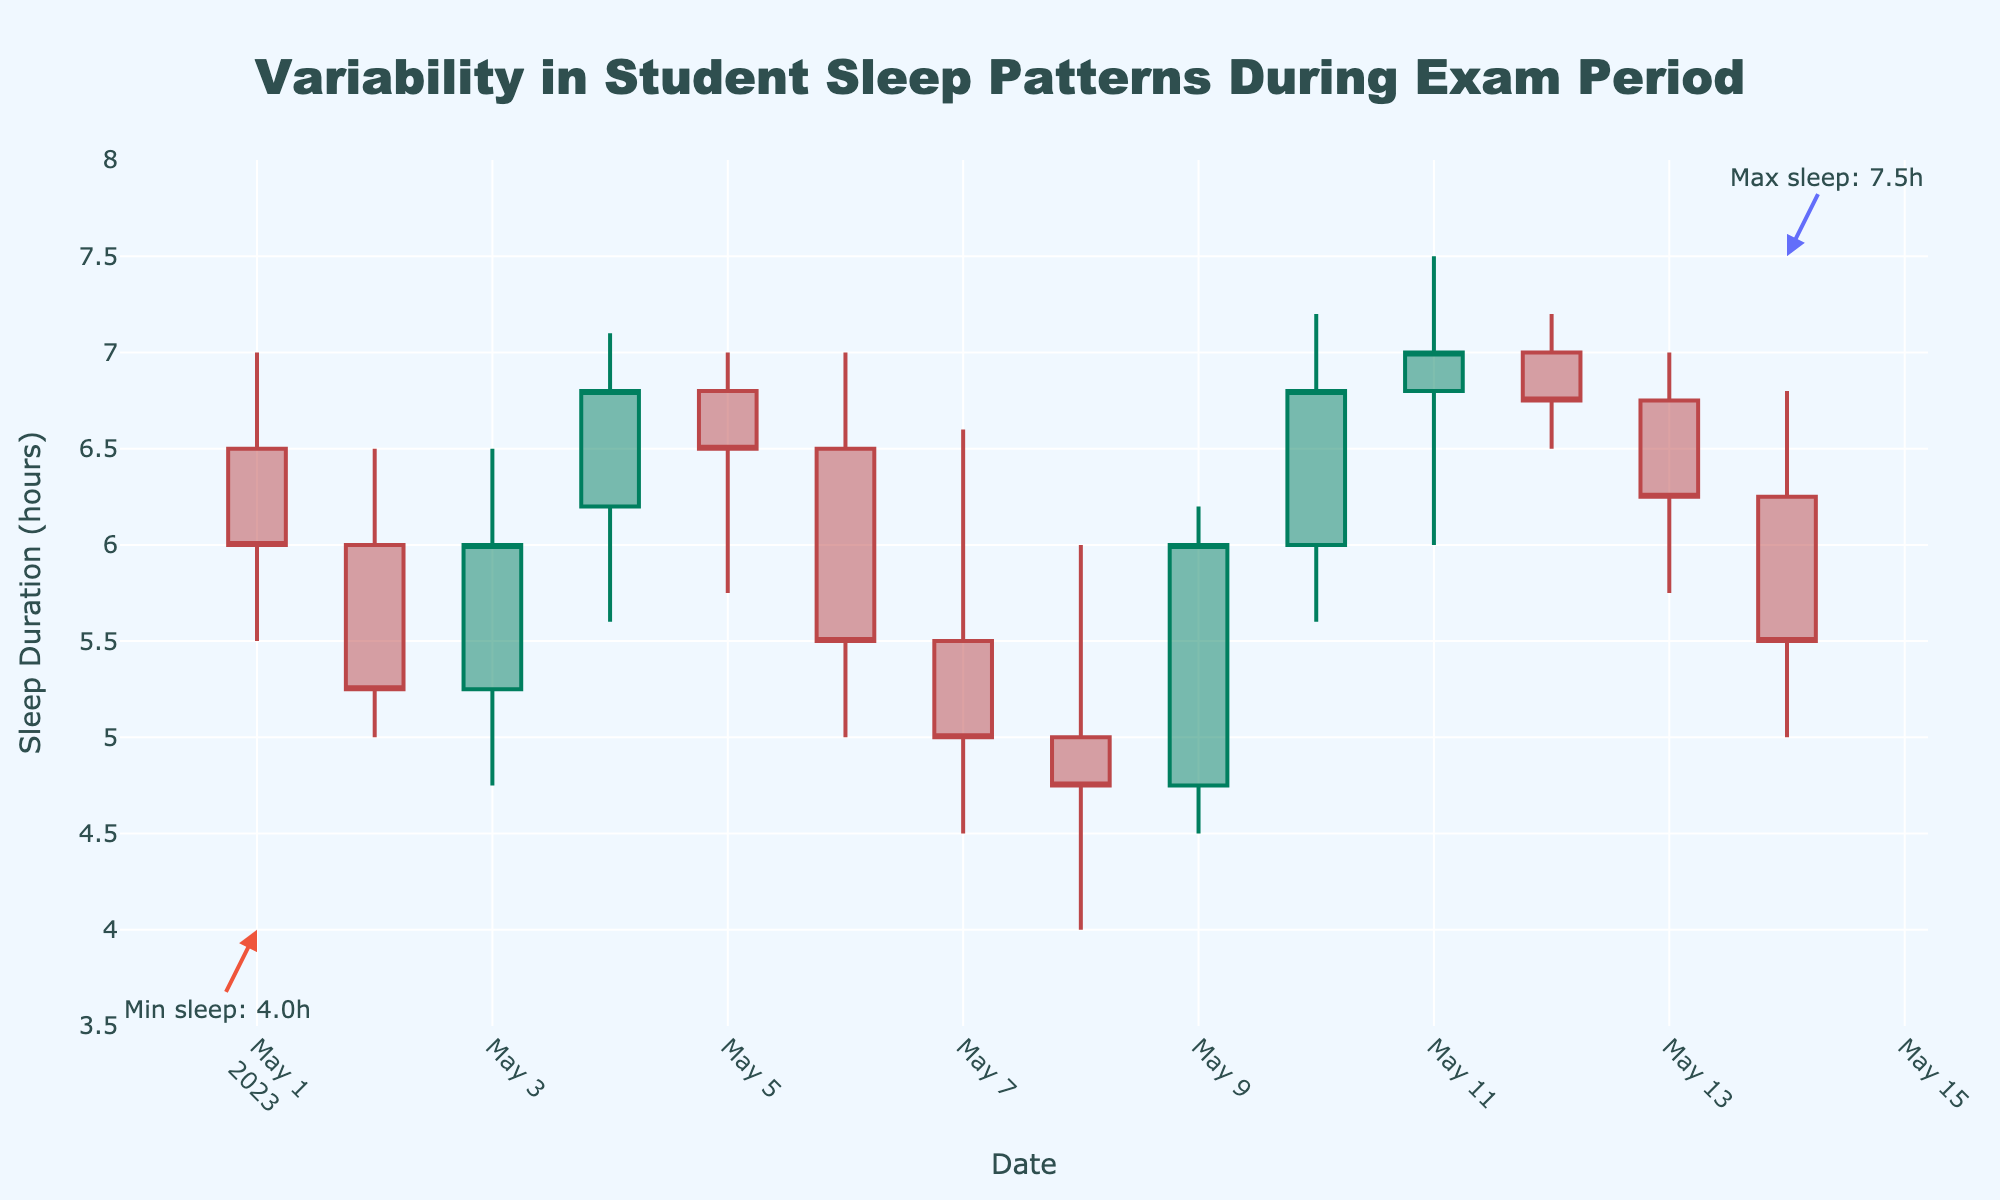What is the title of the figure? The title is prominently displayed at the top of the figure, providing a clear indication of what the plot represents.
Answer: Variability in Student Sleep Patterns During Exam Period How many data points are shown in the plot? Each candlestick represents one data point for a single day. Counting all candlesticks in the plot provides the total number. There are 14 candlesticks from 2023-05-01 to 2023-05-14.
Answer: 14 What is the maximum sleep duration recorded, and on which date did it occur? The highest point on any candlestick indicates the maximum sleep duration. The highest value is annotated on the plot with "Max sleep: 7.5h" on 2023-05-11.
Answer: 7.5 hours on 2023-05-11 What is the minimum sleep duration recorded, and on which date did it occur? The lowest point on any candlestick represents the minimum sleep duration. The lowest value is annotated on the plot with "Min sleep: 4.0h" on 2023-05-08.
Answer: 4.0 hours on 2023-05-08 Which day shows the greatest variability in sleep duration? Variability can be determined by the length of the candlesticks; the longer the candlestick, the greater the variability. The candlestick for 2023-05-10 to 2023-05-11 shows the greatest range.
Answer: 2023-05-10 What is the closing sleep duration on 2023-05-06? The closing value is represented by the top or bottom of the body of the candlestick on the right side. For 2023-05-06, the closing value is near the top of the candlestick at 5.5 hours, as the color indicates a decrease from open.
Answer: 5.5 hours Between which dates did students achieve the longest trend of increasing sleep duration? First, identify the consecutive days where the closing value increases. The longest upward trend occurs from 2023-05-08 to 2023-05-11, with each day closing higher than the previous.
Answer: 2023-05-08 to 2023-05-11 Did the sleep duration generally increase or decrease as the exam period progressed? Observing the overall trend of closing values helps determine if there's a general increase or decrease. Over time, we see mixed variations, but generally, the pattern indicates stabilization.
Answer: Stabilized On which date did the sleep duration open at its highest value, and what was that value? The open value is shown at the top or bottom of the body of the candlestick on the left side. For 2023-05-12, the opening value is at its highest, 7.0 hours.
Answer: 7.0 hours on 2023-05-12 